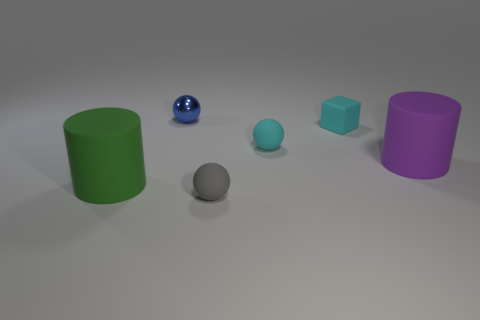What colors are present in the image, and do any of the objects share a color? The image contains objects in green, blue, grey, turquoise, and purple. The two spherical objects share shades of blue, though one is a reflective blue and the other a matte light blue. Which object seems to be the largest and which one is the smallest? The purple cylinder appears to be the largest object in terms of height and volume, while the small blue ball seems to be the smallest in terms of size and scale. 